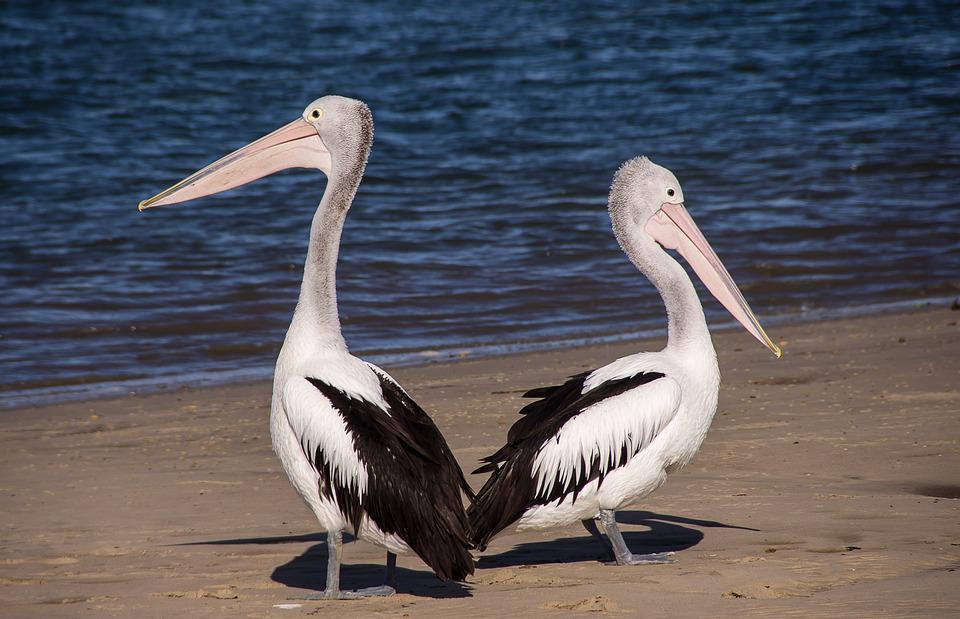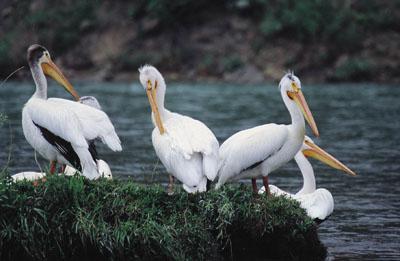The first image is the image on the left, the second image is the image on the right. Assess this claim about the two images: "One of the birds is spreading its wings.". Correct or not? Answer yes or no. No. The first image is the image on the left, the second image is the image on the right. Considering the images on both sides, is "The left image contains at least two large birds at a beach." valid? Answer yes or no. Yes. 